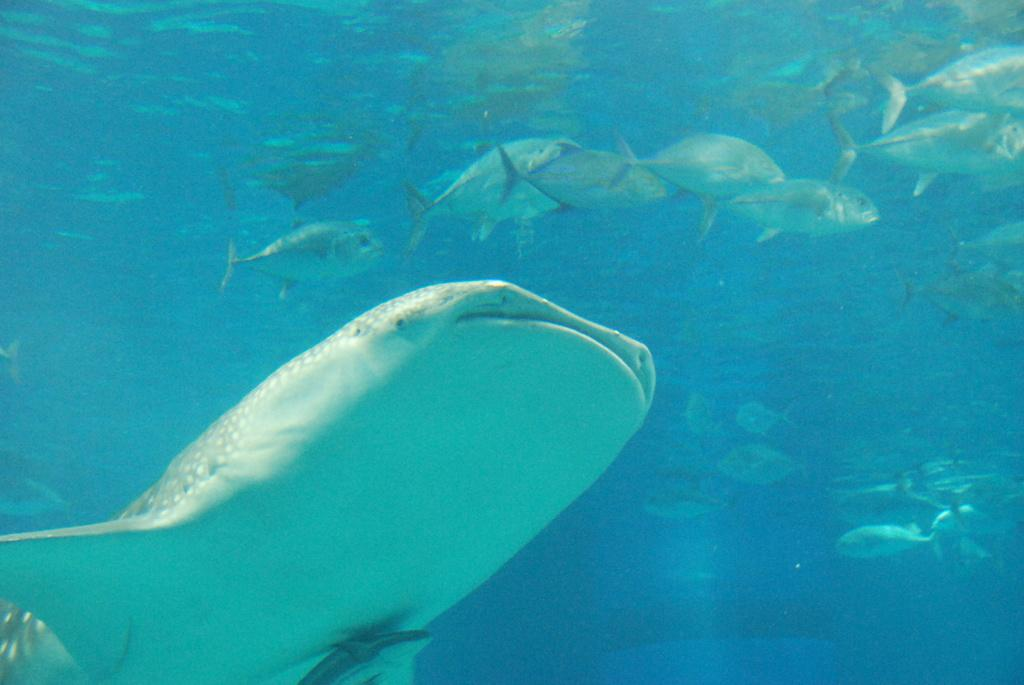What type of animals are in the image? There are fishes in the image. Where are the fishes located? The fishes are in the water. What type of acoustics can be heard from the fishes in the image? There is no indication of any sounds or acoustics in the image, as it features fishes in the water. Is there a net visible in the image? There is no net present in the image. 